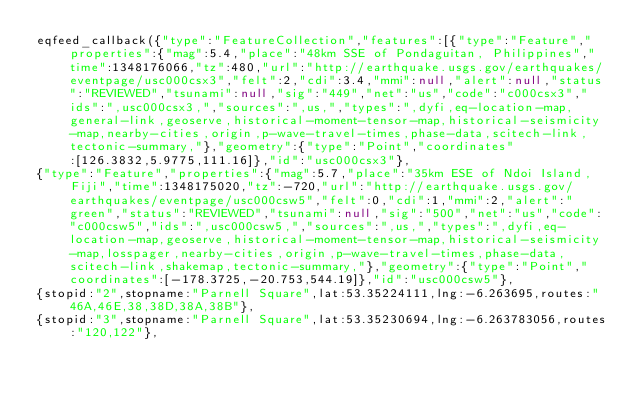<code> <loc_0><loc_0><loc_500><loc_500><_JavaScript_>eqfeed_callback({"type":"FeatureCollection","features":[{"type":"Feature","properties":{"mag":5.4,"place":"48km SSE of Pondaguitan, Philippines","time":1348176066,"tz":480,"url":"http://earthquake.usgs.gov/earthquakes/eventpage/usc000csx3","felt":2,"cdi":3.4,"mmi":null,"alert":null,"status":"REVIEWED","tsunami":null,"sig":"449","net":"us","code":"c000csx3","ids":",usc000csx3,","sources":",us,","types":",dyfi,eq-location-map,general-link,geoserve,historical-moment-tensor-map,historical-seismicity-map,nearby-cities,origin,p-wave-travel-times,phase-data,scitech-link,tectonic-summary,"},"geometry":{"type":"Point","coordinates":[126.3832,5.9775,111.16]},"id":"usc000csx3"},
{"type":"Feature","properties":{"mag":5.7,"place":"35km ESE of Ndoi Island, Fiji","time":1348175020,"tz":-720,"url":"http://earthquake.usgs.gov/earthquakes/eventpage/usc000csw5","felt":0,"cdi":1,"mmi":2,"alert":"green","status":"REVIEWED","tsunami":null,"sig":"500","net":"us","code":"c000csw5","ids":",usc000csw5,","sources":",us,","types":",dyfi,eq-location-map,geoserve,historical-moment-tensor-map,historical-seismicity-map,losspager,nearby-cities,origin,p-wave-travel-times,phase-data,scitech-link,shakemap,tectonic-summary,"},"geometry":{"type":"Point","coordinates":[-178.3725,-20.753,544.19]},"id":"usc000csw5"},
{stopid:"2",stopname:"Parnell Square",lat:53.35224111,lng:-6.263695,routes:"46A,46E,38,38D,38A,38B"},
{stopid:"3",stopname:"Parnell Square",lat:53.35230694,lng:-6.263783056,routes:"120,122"},</code> 